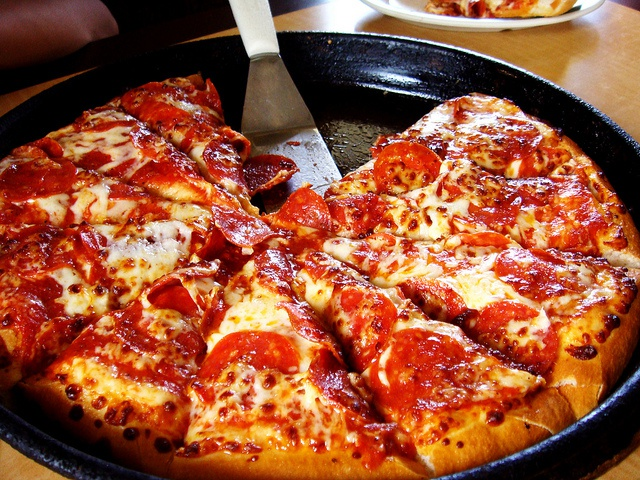Describe the objects in this image and their specific colors. I can see pizza in black, brown, red, and maroon tones, pizza in black, brown, maroon, red, and orange tones, dining table in black, olive, tan, and white tones, and pizza in black, red, orange, brown, and tan tones in this image. 